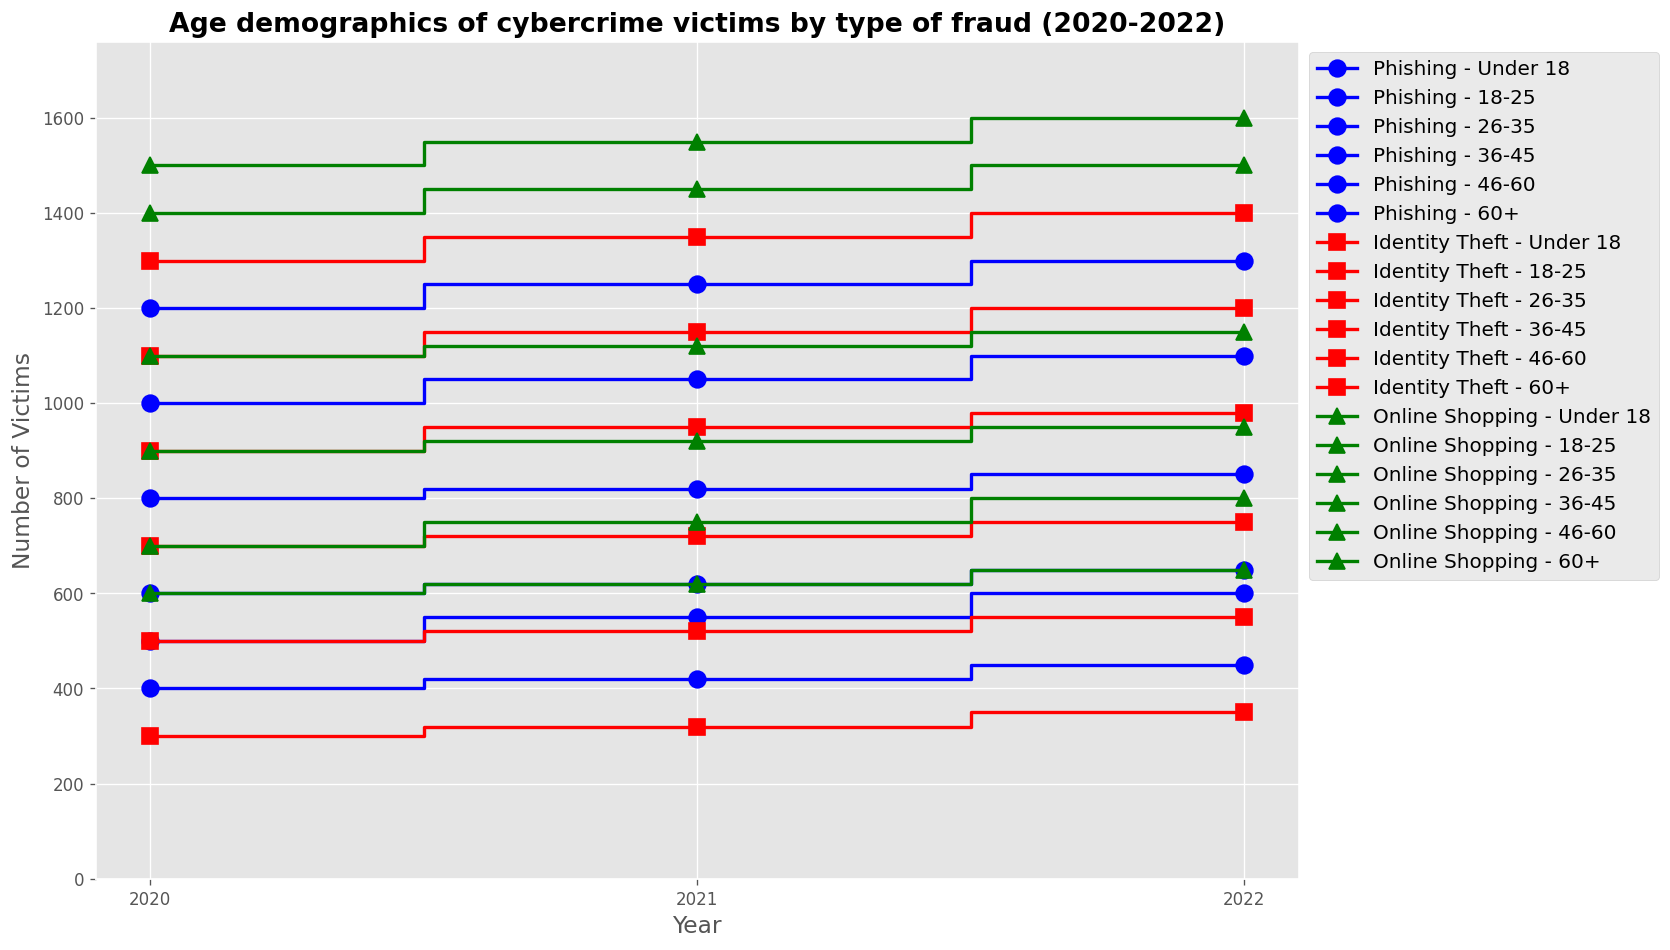What year saw the highest number of phishing victims in the 18-25 age group? Looking at the stairs plot for the 18-25 age group, identify the plot line for phishing (usually marked blue with circles). Observe the peak year for this line.
Answer: 2021 How did the total number of victims for online shopping fraud in the 26-35 age group change from 2020 to 2022? Find the plot lines for online shopping fraud (usually marked green with triangles) in the 26-35 age group. Note the number of victims in 2020 and compare it to the number in 2022.
Answer: Increased by 100 Which age group had a higher number of identity theft victims in 2022: the 36-45 group or the 46-60 group? Identify the plot lines for identity theft (usually marked red with squares) in the 36-45 and 46-60 age groups for 2022. Compare the heights of these lines.
Answer: 36-45 group What is the trend for phishing victims among the under 18 age group from 2020 to 2022? Look at the plot line for phishing in the under 18 age group from 2020 to 2022. Determine if it increases, decreases, or remains stable over the years.
Answer: Increasing In which year did the number of online shopping fraud victims in the 60+ age group reach its peak? Examine the plot line for online shopping fraud in the 60+ age group. Identify the year where this line is at its highest.
Answer: 2022 How many total victims of cybercrime were recorded for the 18-25 age group in 2021, assuming all types of fraud? Identify the number of victims for each type of fraud in the 18-25 age group in 2021 and sum them up: Phishing (1050) + Identity Theft (1150) + Online Shopping (1550).
Answer: 3750 Which type of fraud saw a decrease in victims in the 46-60 age group from 2021 to 2022? Identify plot lines in the 46-60 age group and compare the number of victims for each type of fraud from 2021 to 2022. Determine which one decreased.
Answer: None In 2022, which age group had the lowest number of victims for phishing, and what was the number? Look for the lowest point on the phishing plot lines across all age groups in 2022 and note the age group and number of victims.
Answer: 60+, 450 Compare the trends of identity theft in the 26-35 and 36-45 age groups over the years 2020-2022. Which age group has a steeper increase? Identify the plot lines for identity theft in both age groups and compare the slopes of the increase from 2020 to 2022.
Answer: 26-35 group From 2020 to 2022, how much did the number of online shopping fraud victims change for the under 18 age group? Identify the plot line for online shopping fraud in the under 18 age group. Subtract the number of victims in 2020 from the number in 2022.
Answer: +100 